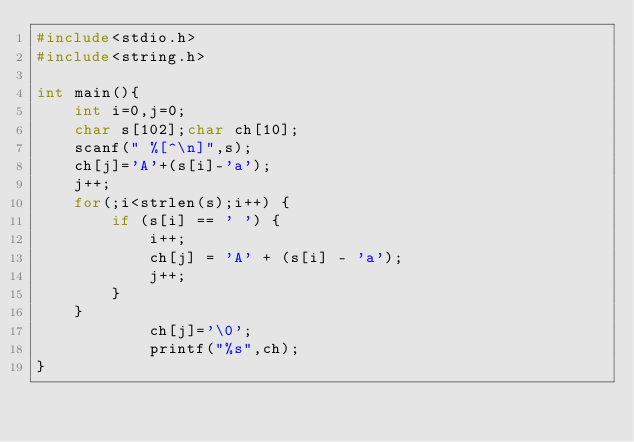Convert code to text. <code><loc_0><loc_0><loc_500><loc_500><_C_>#include<stdio.h>
#include<string.h>

int main(){
    int i=0,j=0;
    char s[102];char ch[10];
    scanf(" %[^\n]",s);
    ch[j]='A'+(s[i]-'a');
    j++;
    for(;i<strlen(s);i++) {
        if (s[i] == ' ') {
            i++;
            ch[j] = 'A' + (s[i] - 'a');
            j++;
        }
    }
            ch[j]='\0';
            printf("%s",ch);
}</code> 